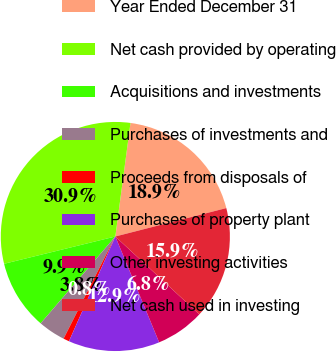Convert chart to OTSL. <chart><loc_0><loc_0><loc_500><loc_500><pie_chart><fcel>Year Ended December 31<fcel>Net cash provided by operating<fcel>Acquisitions and investments<fcel>Purchases of investments and<fcel>Proceeds from disposals of<fcel>Purchases of property plant<fcel>Other investing activities<fcel>Net cash used in investing<nl><fcel>18.9%<fcel>30.94%<fcel>9.87%<fcel>3.84%<fcel>0.83%<fcel>12.88%<fcel>6.85%<fcel>15.89%<nl></chart> 